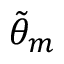<formula> <loc_0><loc_0><loc_500><loc_500>\tilde { \theta } _ { m }</formula> 